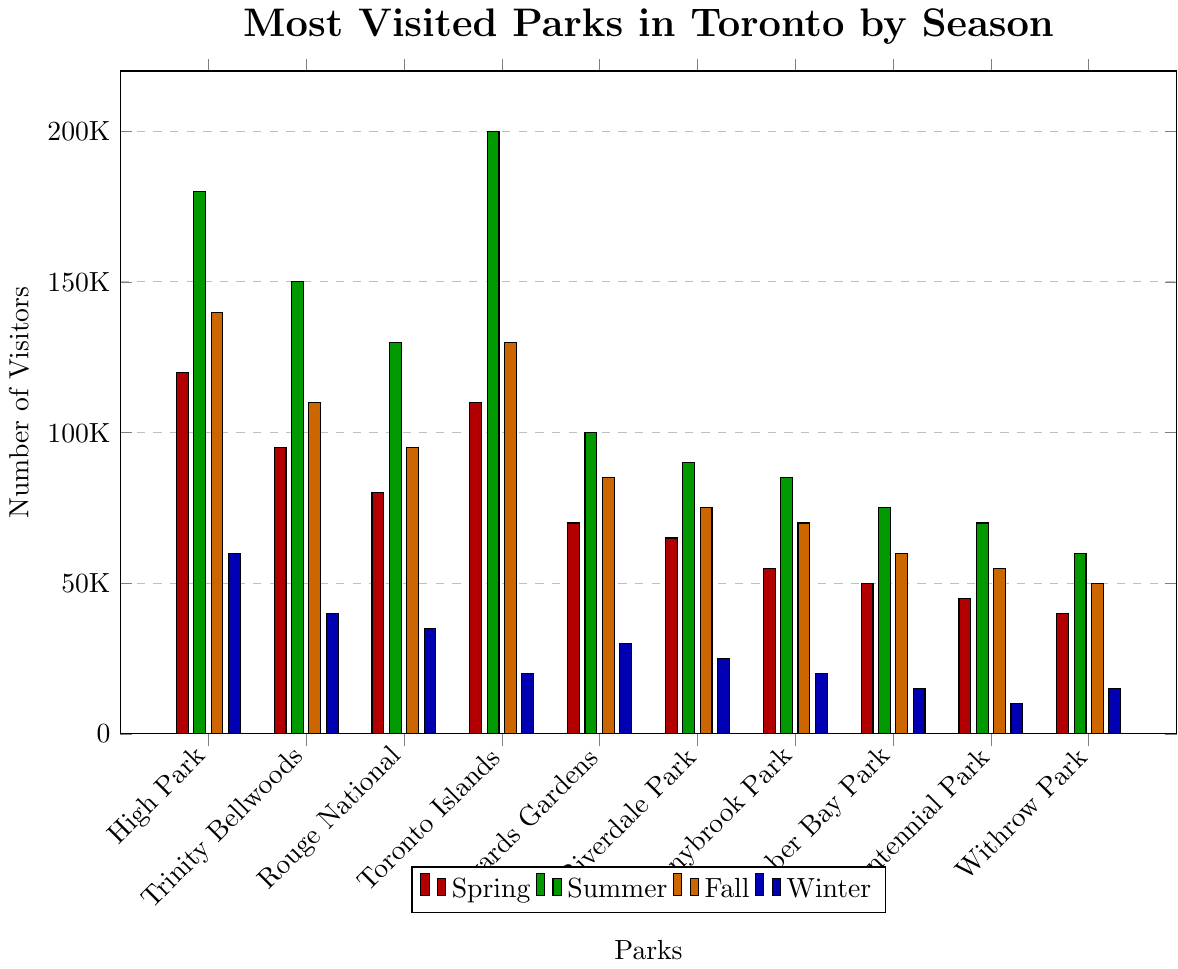which season has the highest visitation for Toronto Islands? The bar representing Toronto Islands is highest in summer. Therefore, summer has the highest visitation.
Answer: Summer what is the total number of visitors to High Park across all seasons? Sum the number of visitors to High Park for each season: 120,000 (Spring) + 180,000 (Summer) + 140,000 (Fall) + 60,000 (Winter). This sums up to 500,000.
Answer: 500,000 which park has the lowest number of visitors in winter? The bar representing Winter is the smallest for Centennial Park, so it has the lowest visitors in winter.
Answer: Centennial Park is the number of visitors to High Park in summer greater than the combined number of visitors to Humber Bay Park and Sunnybrook Park in fall? High Park in summer has 180,000 visitors. Humber Bay Park in fall has 60,000 visitors, and Sunnybrook Park in fall has 70,000 visitors. Combined, they have 60,000 + 70,000 = 130,000 visitors. Since 180,000 > 130,000, the answer is yes.
Answer: Yes how many more visitors did Trinity Bellwoods Park have in spring compared to winter? Trinity Bellwoods Park had 95,000 visitors in spring and 40,000 in winter. The difference is 95,000 - 40,000 = 55,000.
Answer: 55,000 which season generally sees the highest visitation across all parks? By observing the bars for each park, summer tends to have the tallest bars, indicating the highest visitation.
Answer: Summer comparing Edwards Gardens in summer and Riverdale Park in fall, which one had more visitors? The bar for Edwards Gardens in summer (100,000) is higher than that of Riverdale Park in fall (75,000).
Answer: Edwards Gardens what is the average number of visitors to Rouge National Urban Park across all seasons? Sum the number of visitors: 80,000 (Spring) + 130,000 (Summer) + 95,000 (Fall) + 35,000 (Winter) = 340,000. The average is 340,000 / 4 = 85,000.
Answer: 85,000 which park had the highest increase in visitors from winter to summer? Calculate the increase from winter to summer for each park and find the one with the highest value:
- High Park: 180,000 - 60,000 = 120,000
- Trinity Bellwoods Park: 150,000 - 40,000 = 110,000
- Rouge National Urban Park: 130,000 - 35,000 = 95,000
- Toronto Islands: 200,000 - 20,000 = 180,000
- Edwards Gardens: 100,000 - 30,000 = 70,000
- Riverdale Park: 90,000 - 25,000 = 65,000
- Sunnybrook Park: 85,000 - 20,000 = 65,000
- Humber Bay Park: 75,000 - 15,000 = 60,000
- Centennial Park: 70,000 - 10,000 = 60,000
- Withrow Park: 60,000 - 15,000 = 45,000
Toronto Islands had the highest increase with 180,000.
Answer: Toronto Islands 